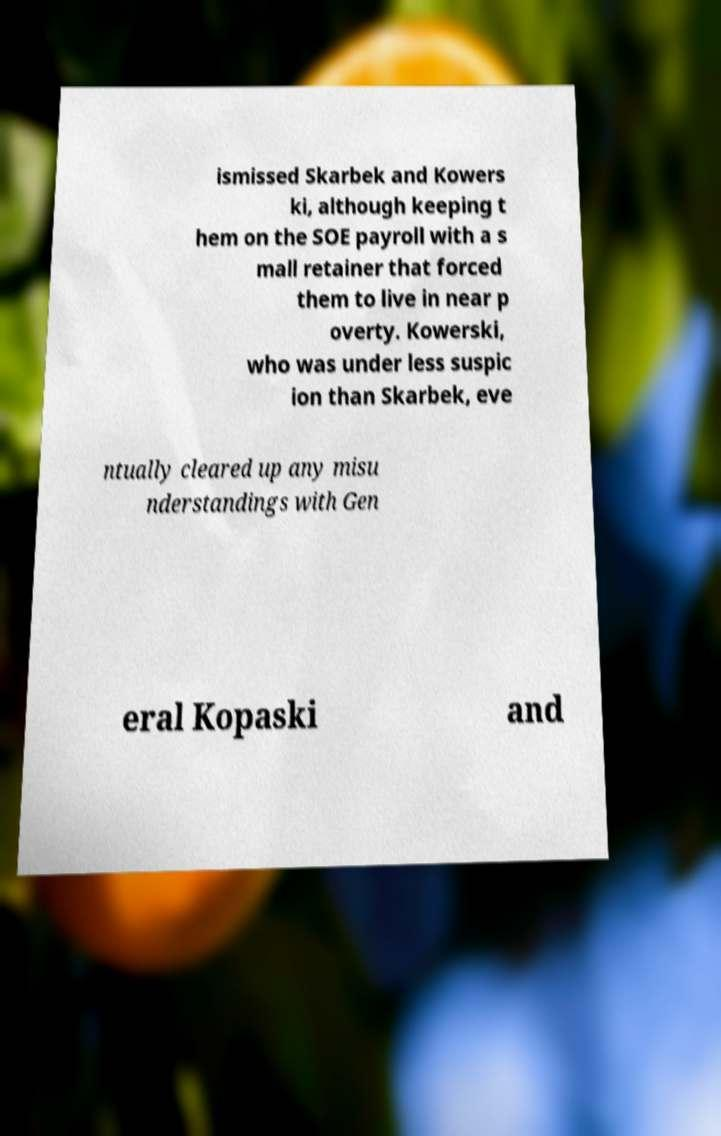Please identify and transcribe the text found in this image. ismissed Skarbek and Kowers ki, although keeping t hem on the SOE payroll with a s mall retainer that forced them to live in near p overty. Kowerski, who was under less suspic ion than Skarbek, eve ntually cleared up any misu nderstandings with Gen eral Kopaski and 